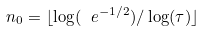<formula> <loc_0><loc_0><loc_500><loc_500>n _ { 0 } = \lfloor \log ( \ e ^ { - 1 / 2 } ) / \log ( \tau ) \rfloor</formula> 